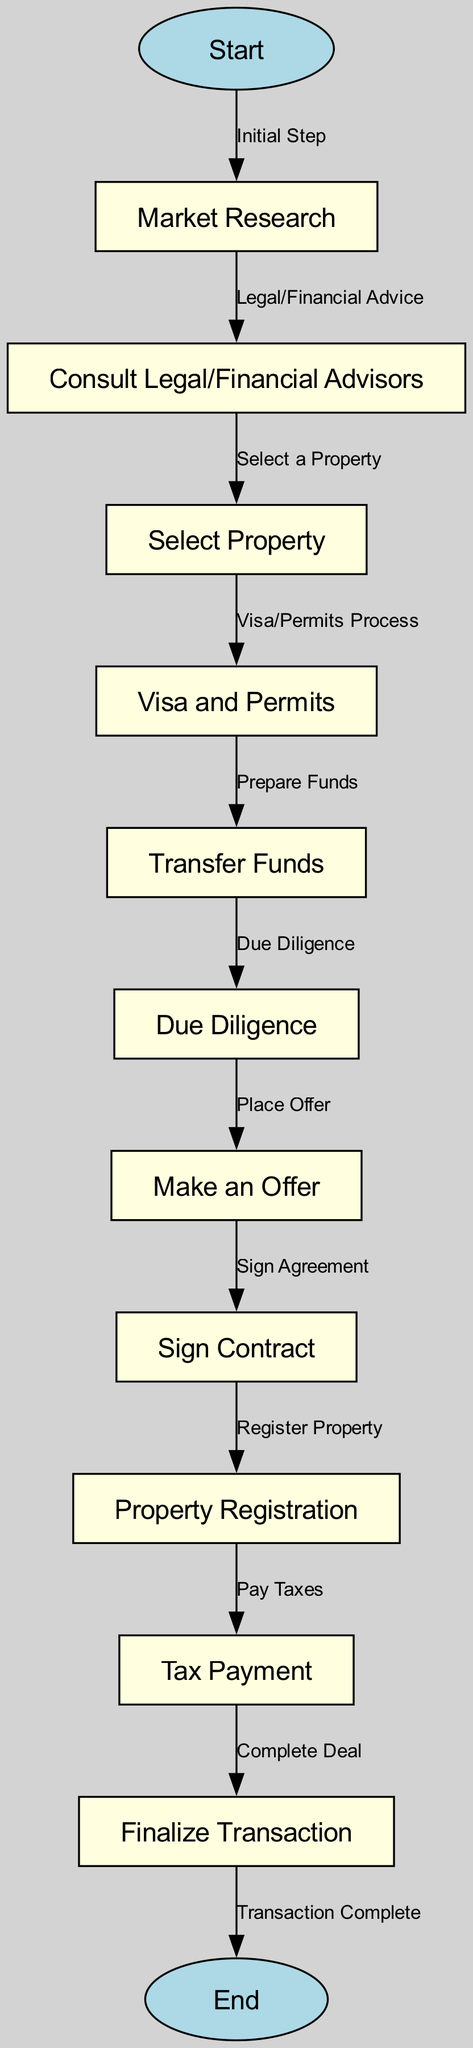What's the first step in the process? The first step in the diagram is labeled "Market Research," which directly follows the "Start" node. This node indicates where the procedure begins for foreign investors.
Answer: Market Research How many nodes are present in the diagram? The diagram contains a total of 13 nodes when counting both start and end nodes along with all the legal and financial steps listed in between.
Answer: 13 What node comes after 'Property Registration'? Following the 'Property Registration' node, the next step in the sequence is 'Tax Payment.' This is evident from the directed edge that connects these two nodes.
Answer: Tax Payment Describe the relationship between 'Make an Offer' and 'Sign Contract.' The relationship is that 'Make an Offer' precedes 'Sign Contract.' After due diligence, the investor places an offer, which must be agreed upon before a contract is signed.
Answer: 'Make an Offer' precedes 'Sign Contract' What is involved before transferring funds? Prior to transferring funds, the process requires completing the 'Visa and Permits' step. This step must be completed to legally proceed with the fund transfer.
Answer: Visa and Permits List the steps that occur after 'Due Diligence.' After completing 'Due Diligence,' the steps include 'Make an Offer,' followed by 'Sign Contract,' then 'Property Registration,' and finally 'Tax Payment.' This shows the progression through major phases after due diligence.
Answer: Make an Offer, Sign Contract, Property Registration, Tax Payment How does 'Select Property' relate to 'Consult Legal/Financial Advisors'? 'Select Property' comes after 'Consult Legal/Financial Advisors.' The advisor step is necessary to ensure that the selection of the property is made with informed legal and financial advice.
Answer: 'Select Property' follows 'Consult Legal/Financial Advisors' What is the last step in the process? The last step in the diagram, which signifies the conclusion of the transaction process for foreign investors, is labeled 'End.' This node indicates that all necessary steps have been completed successfully.
Answer: End 